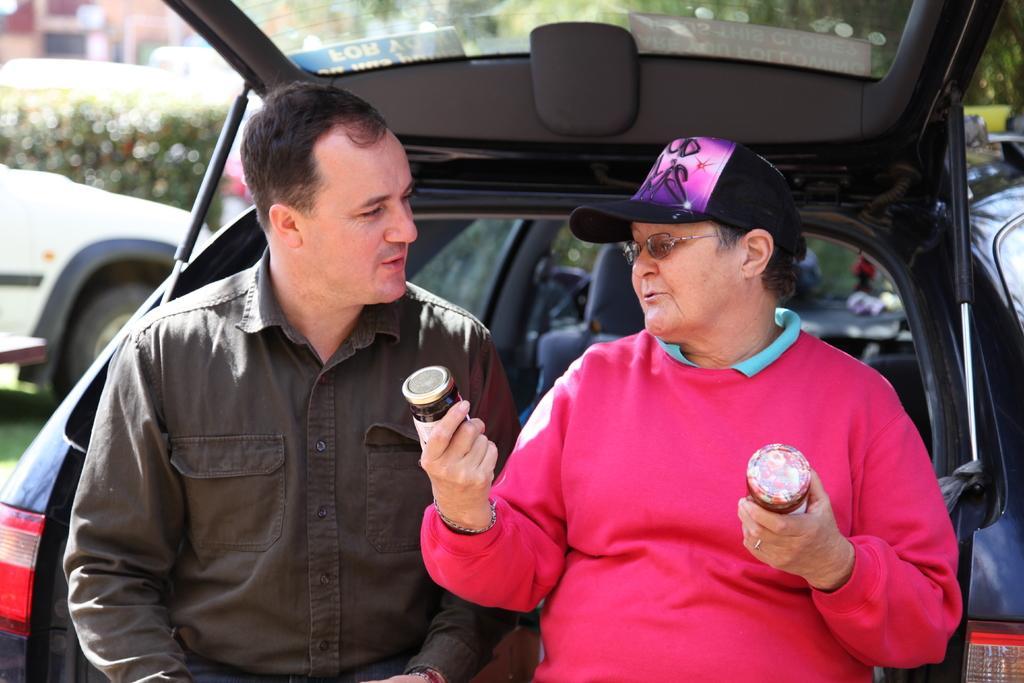Could you give a brief overview of what you see in this image? In this image I can see two men where one is holding bottles. I can also see he is wearing a specs and a cap. In the background I can see few vehicles and trees. 